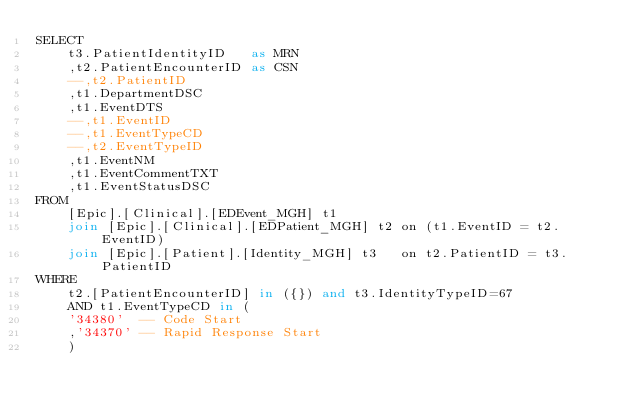<code> <loc_0><loc_0><loc_500><loc_500><_SQL_>SELECT
    t3.PatientIdentityID   as MRN
    ,t2.PatientEncounterID as CSN
    --,t2.PatientID
    ,t1.DepartmentDSC
    ,t1.EventDTS
    --,t1.EventID
    --,t1.EventTypeCD
    --,t2.EventTypeID
    ,t1.EventNM
    ,t1.EventCommentTXT
    ,t1.EventStatusDSC
FROM
    [Epic].[Clinical].[EDEvent_MGH] t1
    join [Epic].[Clinical].[EDPatient_MGH] t2 on (t1.EventID = t2.EventID)
    join [Epic].[Patient].[Identity_MGH] t3   on t2.PatientID = t3.PatientID
WHERE
    t2.[PatientEncounterID] in ({}) and t3.IdentityTypeID=67
    AND t1.EventTypeCD in (
	'34380'  -- Code Start
	,'34370' -- Rapid Response Start
    )
</code> 